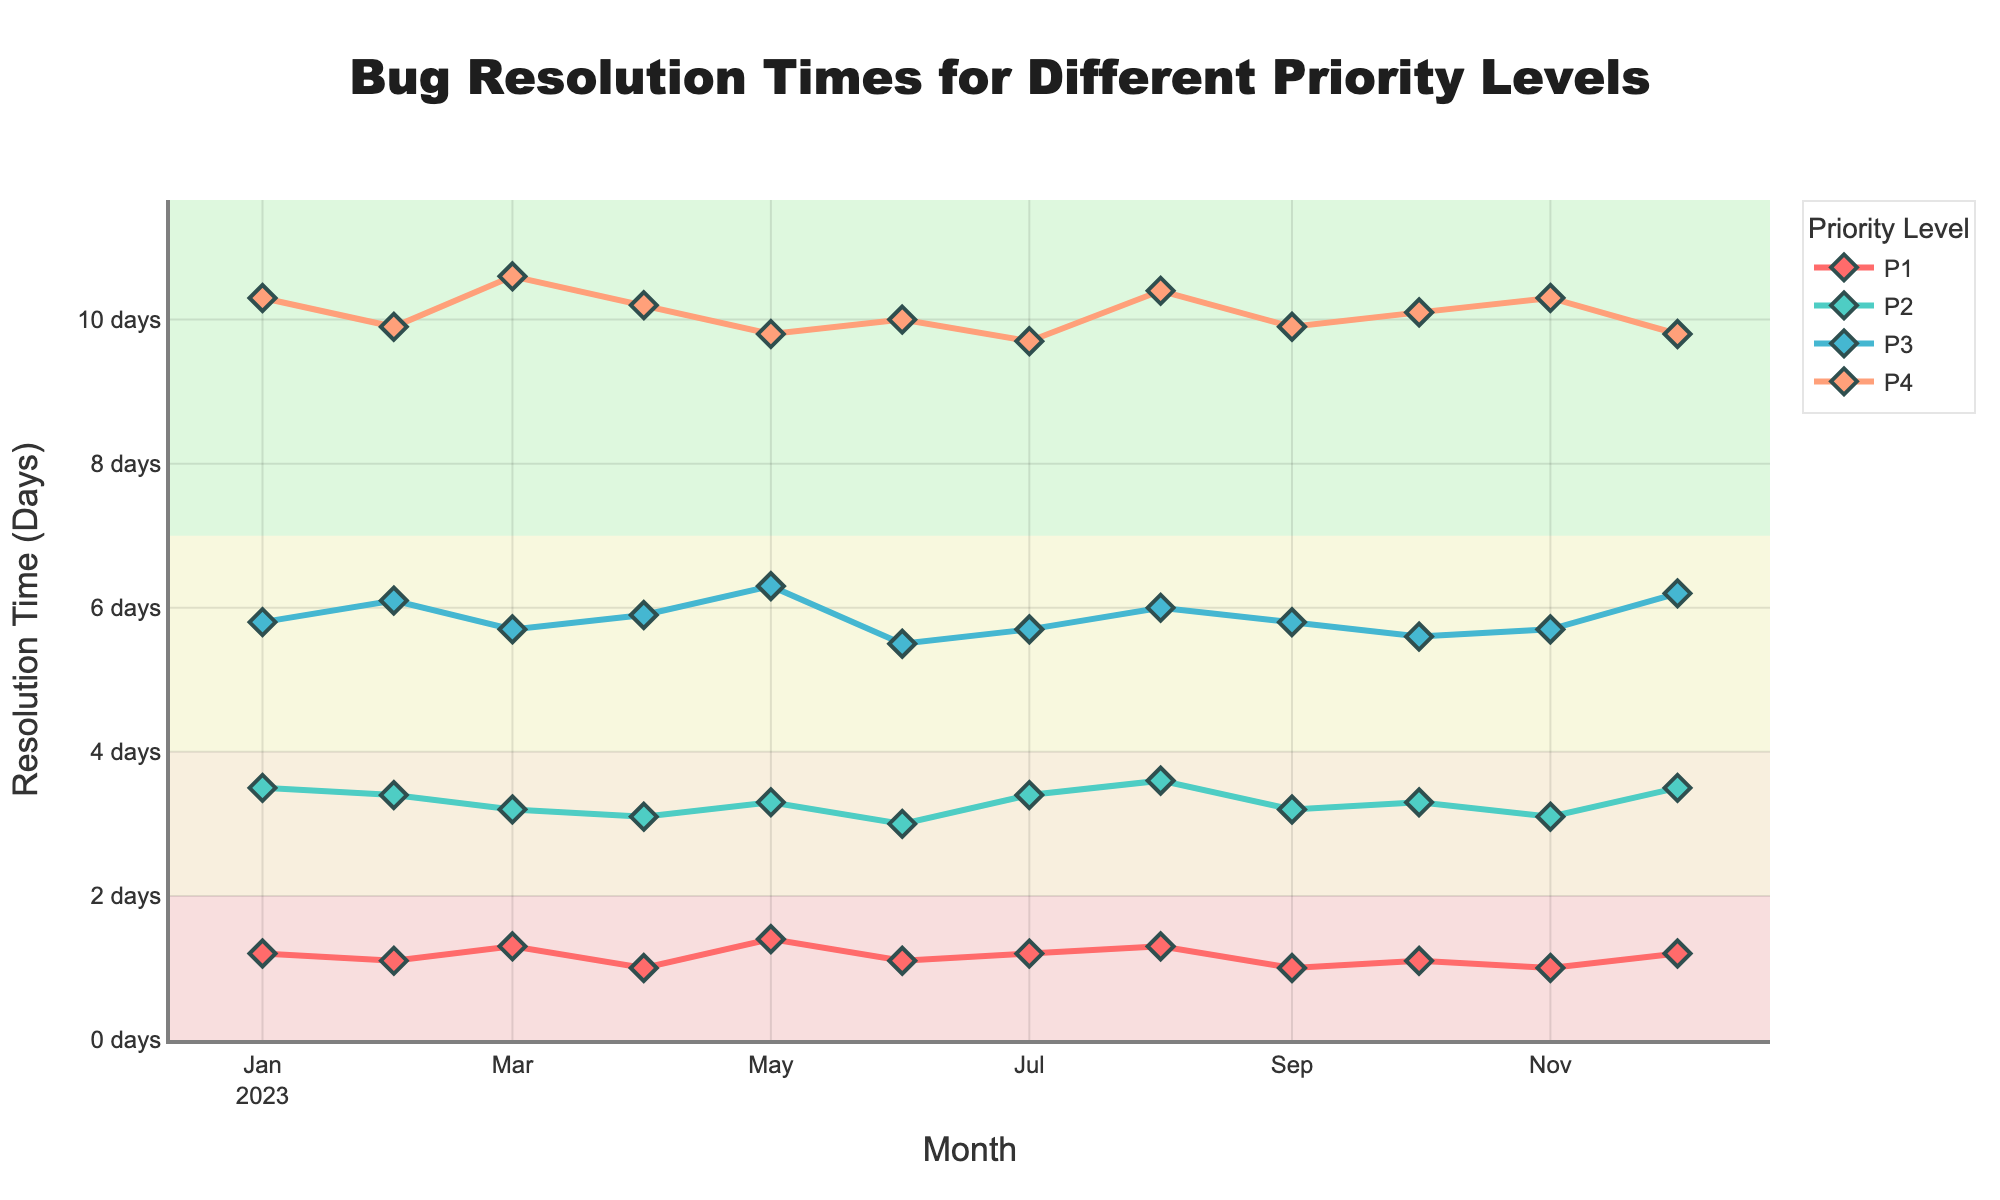What is the title of the plot? The title is located at the top of the plot and describes its content.
Answer: Bug Resolution Times for Different Priority Levels What is the y-axis title? The y-axis title appears on the left side of the plot and indicates the variable it represents.
Answer: Resolution Time (Days) How many different priority levels are shown in the plot? The legend on the right side of the plot lists all the priority levels being tracked.
Answer: 4 Which priority level had the highest resolution time in March 2023? Look at the data points for March 2023 and identify the one with the highest value.
Answer: P4 Did the resolution time for P1 increase or decrease from January to December 2023? Compare the resolution time of P1 for January and December; check if it increases or decreases.
Answer: Remained the same (1.2 days) What is the average resolution time for P2 over the entire year? Sum all monthly resolution times for P2 and divide by the number of months (12).
Answer: (3.5+3.4+3.2+3.1+3.3+3.0+3.4+3.6+3.2+3.3+3.1+3.5)/12 = 3.3 days Which priority level showed the most significant decrease in resolution time from the beginning to the end of the year? Calculate the difference in resolution time from January to December for each priority level and identify the largest decrease.
Answer: P4 (10.3 to 9.8) In which month did P3 experience the highest resolution time? Scan through the data points for P3 and identify the month with the highest resolution time.
Answer: May 2023 How do the resolution times for P1 and P2 compare in August 2023? Locate both data points for August 2023 and compare their resolution times.
Answer: P1: 1.3 days, P2: 3.6 days What is the trend in resolution times for P4 from July to December 2023? Observe the data points for P4 from July to December and describe the overall pattern.
Answer: Mixed trend with a slight decrease 